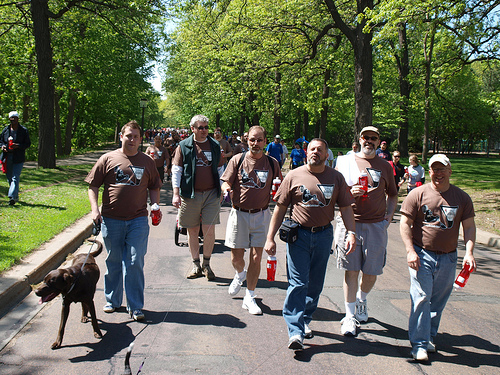<image>
Is the dog to the left of the dirt patch? Yes. From this viewpoint, the dog is positioned to the left side relative to the dirt patch. Where is the dog in relation to the man? Is it in front of the man? No. The dog is not in front of the man. The spatial positioning shows a different relationship between these objects. 